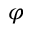<formula> <loc_0><loc_0><loc_500><loc_500>\varphi</formula> 